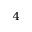<formula> <loc_0><loc_0><loc_500><loc_500>^ { 4 }</formula> 